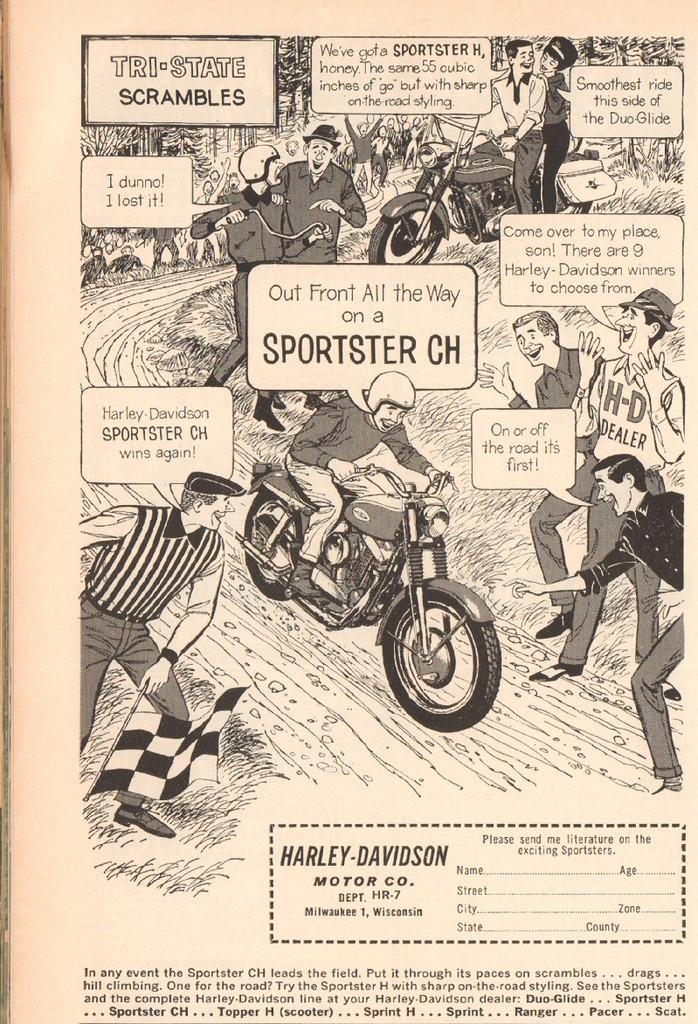What is present on the paper in the image? The paper contains text. What are the people in the image doing? There are people standing and riding motorcycles in the image. What type of berry can be seen growing on the paper in the image? There are no berries present on the paper in the image; it contains text. 